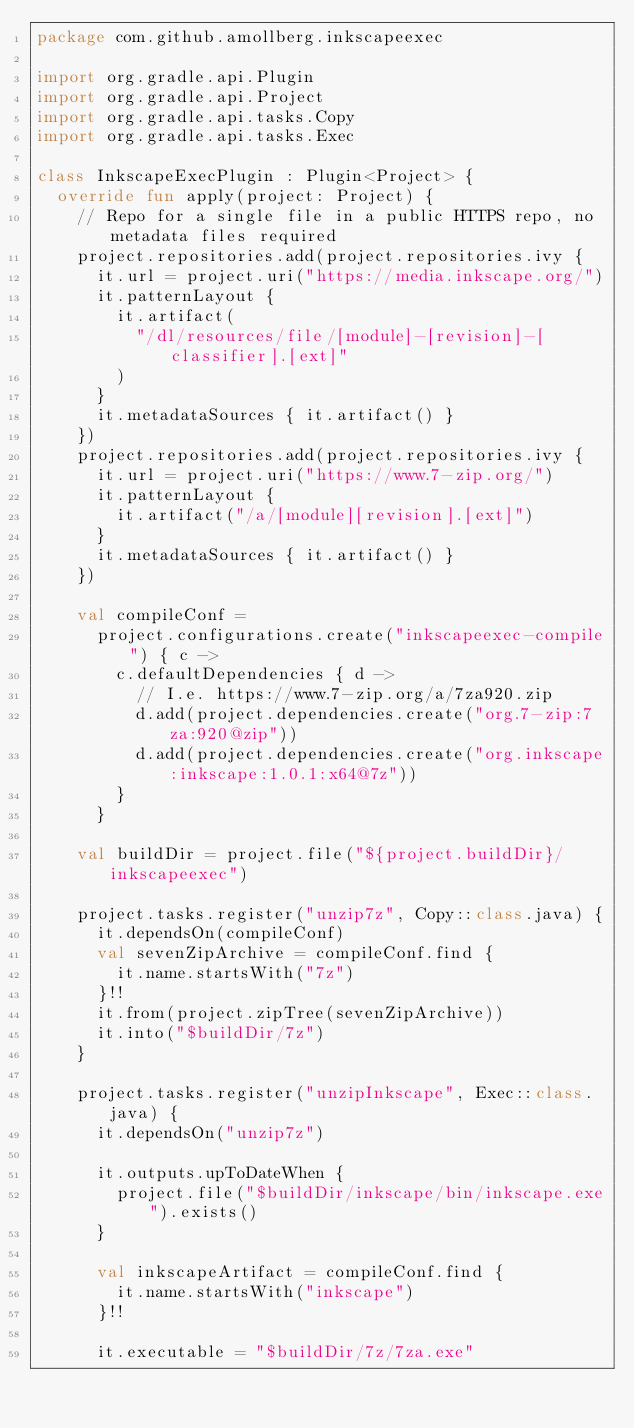Convert code to text. <code><loc_0><loc_0><loc_500><loc_500><_Kotlin_>package com.github.amollberg.inkscapeexec

import org.gradle.api.Plugin
import org.gradle.api.Project
import org.gradle.api.tasks.Copy
import org.gradle.api.tasks.Exec

class InkscapeExecPlugin : Plugin<Project> {
  override fun apply(project: Project) {
    // Repo for a single file in a public HTTPS repo, no metadata files required
    project.repositories.add(project.repositories.ivy {
      it.url = project.uri("https://media.inkscape.org/")
      it.patternLayout {
        it.artifact(
          "/dl/resources/file/[module]-[revision]-[classifier].[ext]"
        )
      }
      it.metadataSources { it.artifact() }
    })
    project.repositories.add(project.repositories.ivy {
      it.url = project.uri("https://www.7-zip.org/")
      it.patternLayout {
        it.artifact("/a/[module][revision].[ext]")
      }
      it.metadataSources { it.artifact() }
    })

    val compileConf =
      project.configurations.create("inkscapeexec-compile") { c ->
        c.defaultDependencies { d ->
          // I.e. https://www.7-zip.org/a/7za920.zip
          d.add(project.dependencies.create("org.7-zip:7za:920@zip"))
          d.add(project.dependencies.create("org.inkscape:inkscape:1.0.1:x64@7z"))
        }
      }

    val buildDir = project.file("${project.buildDir}/inkscapeexec")

    project.tasks.register("unzip7z", Copy::class.java) {
      it.dependsOn(compileConf)
      val sevenZipArchive = compileConf.find {
        it.name.startsWith("7z")
      }!!
      it.from(project.zipTree(sevenZipArchive))
      it.into("$buildDir/7z")
    }

    project.tasks.register("unzipInkscape", Exec::class.java) {
      it.dependsOn("unzip7z")

      it.outputs.upToDateWhen {
        project.file("$buildDir/inkscape/bin/inkscape.exe").exists()
      }

      val inkscapeArtifact = compileConf.find {
        it.name.startsWith("inkscape")
      }!!

      it.executable = "$buildDir/7z/7za.exe"</code> 